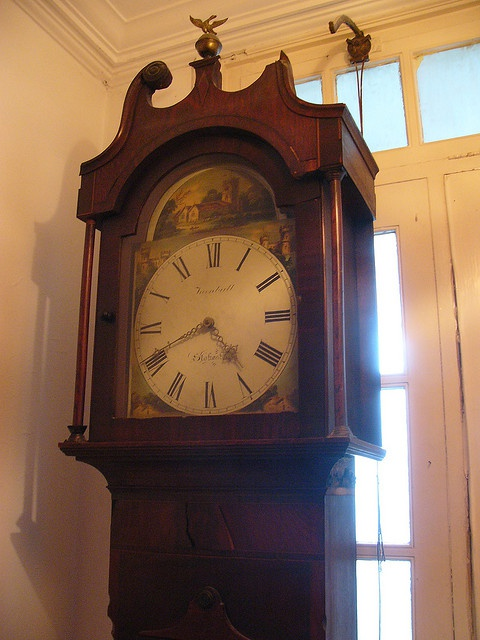Describe the objects in this image and their specific colors. I can see a clock in tan, maroon, olive, and gray tones in this image. 